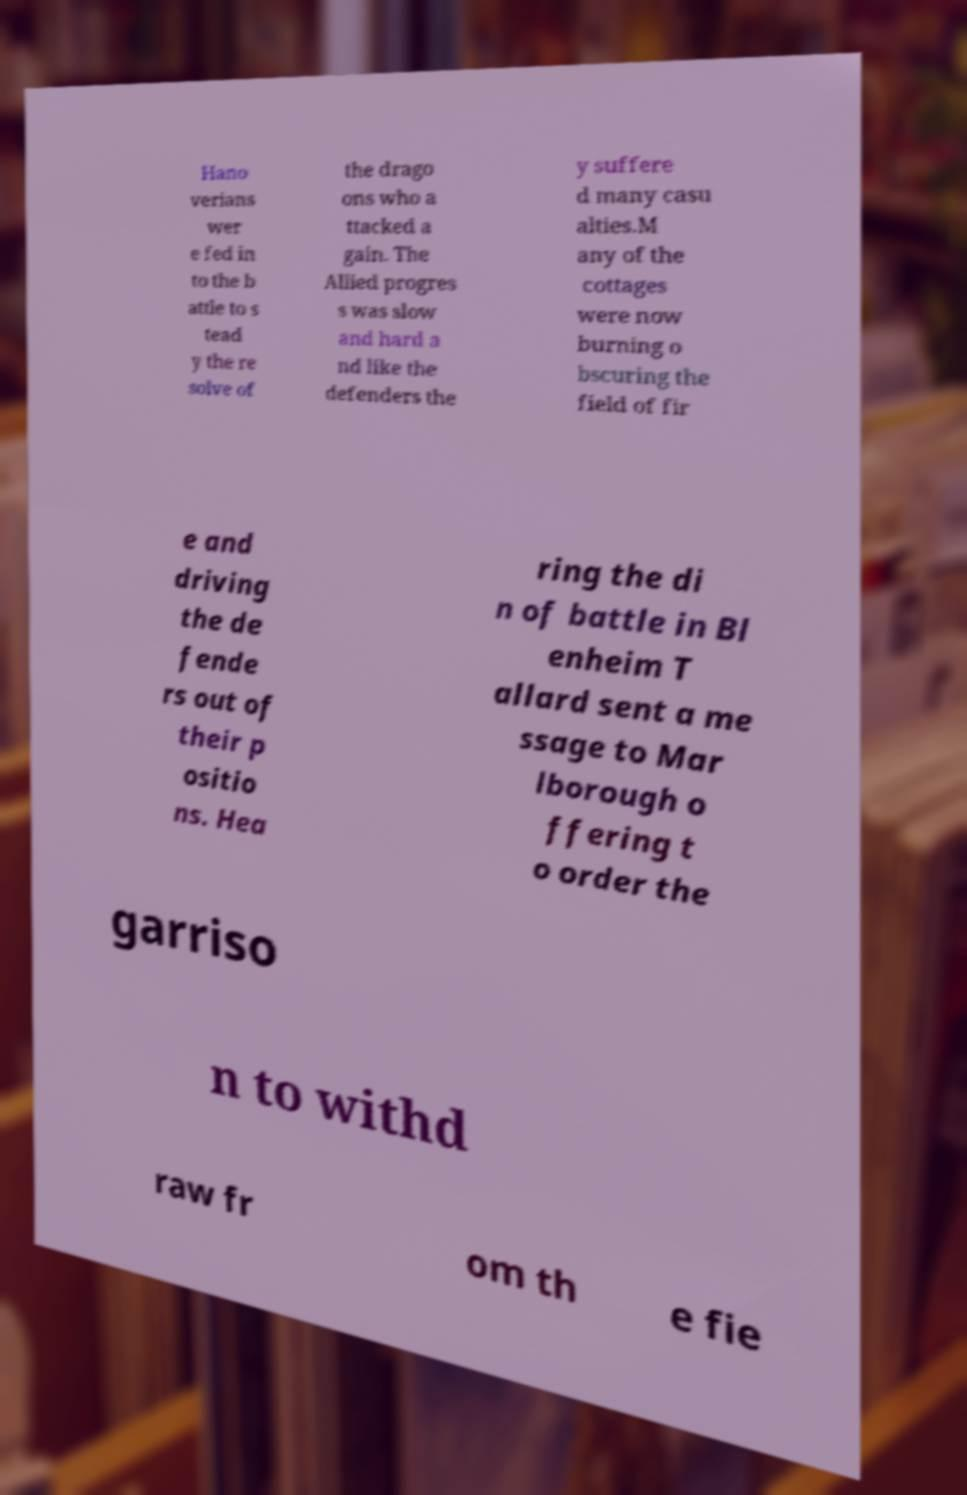For documentation purposes, I need the text within this image transcribed. Could you provide that? Hano verians wer e fed in to the b attle to s tead y the re solve of the drago ons who a ttacked a gain. The Allied progres s was slow and hard a nd like the defenders the y suffere d many casu alties.M any of the cottages were now burning o bscuring the field of fir e and driving the de fende rs out of their p ositio ns. Hea ring the di n of battle in Bl enheim T allard sent a me ssage to Mar lborough o ffering t o order the garriso n to withd raw fr om th e fie 